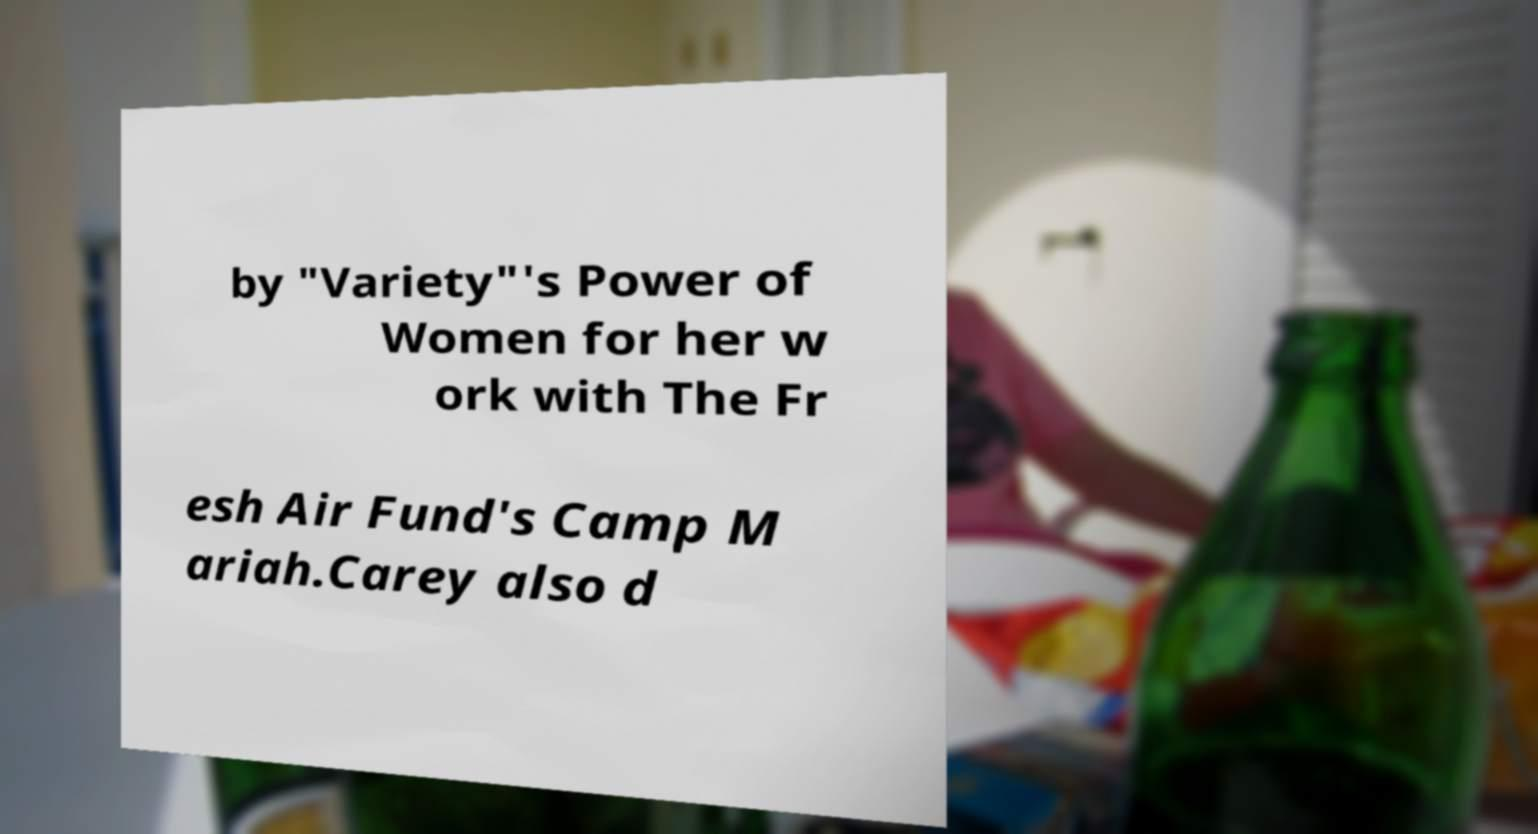Please read and relay the text visible in this image. What does it say? by "Variety"'s Power of Women for her w ork with The Fr esh Air Fund's Camp M ariah.Carey also d 